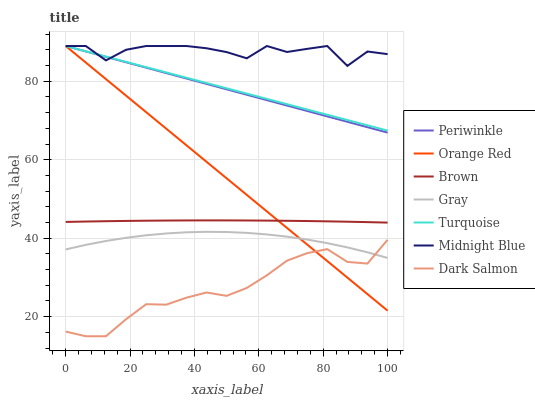Does Dark Salmon have the minimum area under the curve?
Answer yes or no. Yes. Does Midnight Blue have the maximum area under the curve?
Answer yes or no. Yes. Does Turquoise have the minimum area under the curve?
Answer yes or no. No. Does Turquoise have the maximum area under the curve?
Answer yes or no. No. Is Orange Red the smoothest?
Answer yes or no. Yes. Is Midnight Blue the roughest?
Answer yes or no. Yes. Is Turquoise the smoothest?
Answer yes or no. No. Is Turquoise the roughest?
Answer yes or no. No. Does Dark Salmon have the lowest value?
Answer yes or no. Yes. Does Turquoise have the lowest value?
Answer yes or no. No. Does Orange Red have the highest value?
Answer yes or no. Yes. Does Gray have the highest value?
Answer yes or no. No. Is Dark Salmon less than Brown?
Answer yes or no. Yes. Is Midnight Blue greater than Gray?
Answer yes or no. Yes. Does Turquoise intersect Orange Red?
Answer yes or no. Yes. Is Turquoise less than Orange Red?
Answer yes or no. No. Is Turquoise greater than Orange Red?
Answer yes or no. No. Does Dark Salmon intersect Brown?
Answer yes or no. No. 